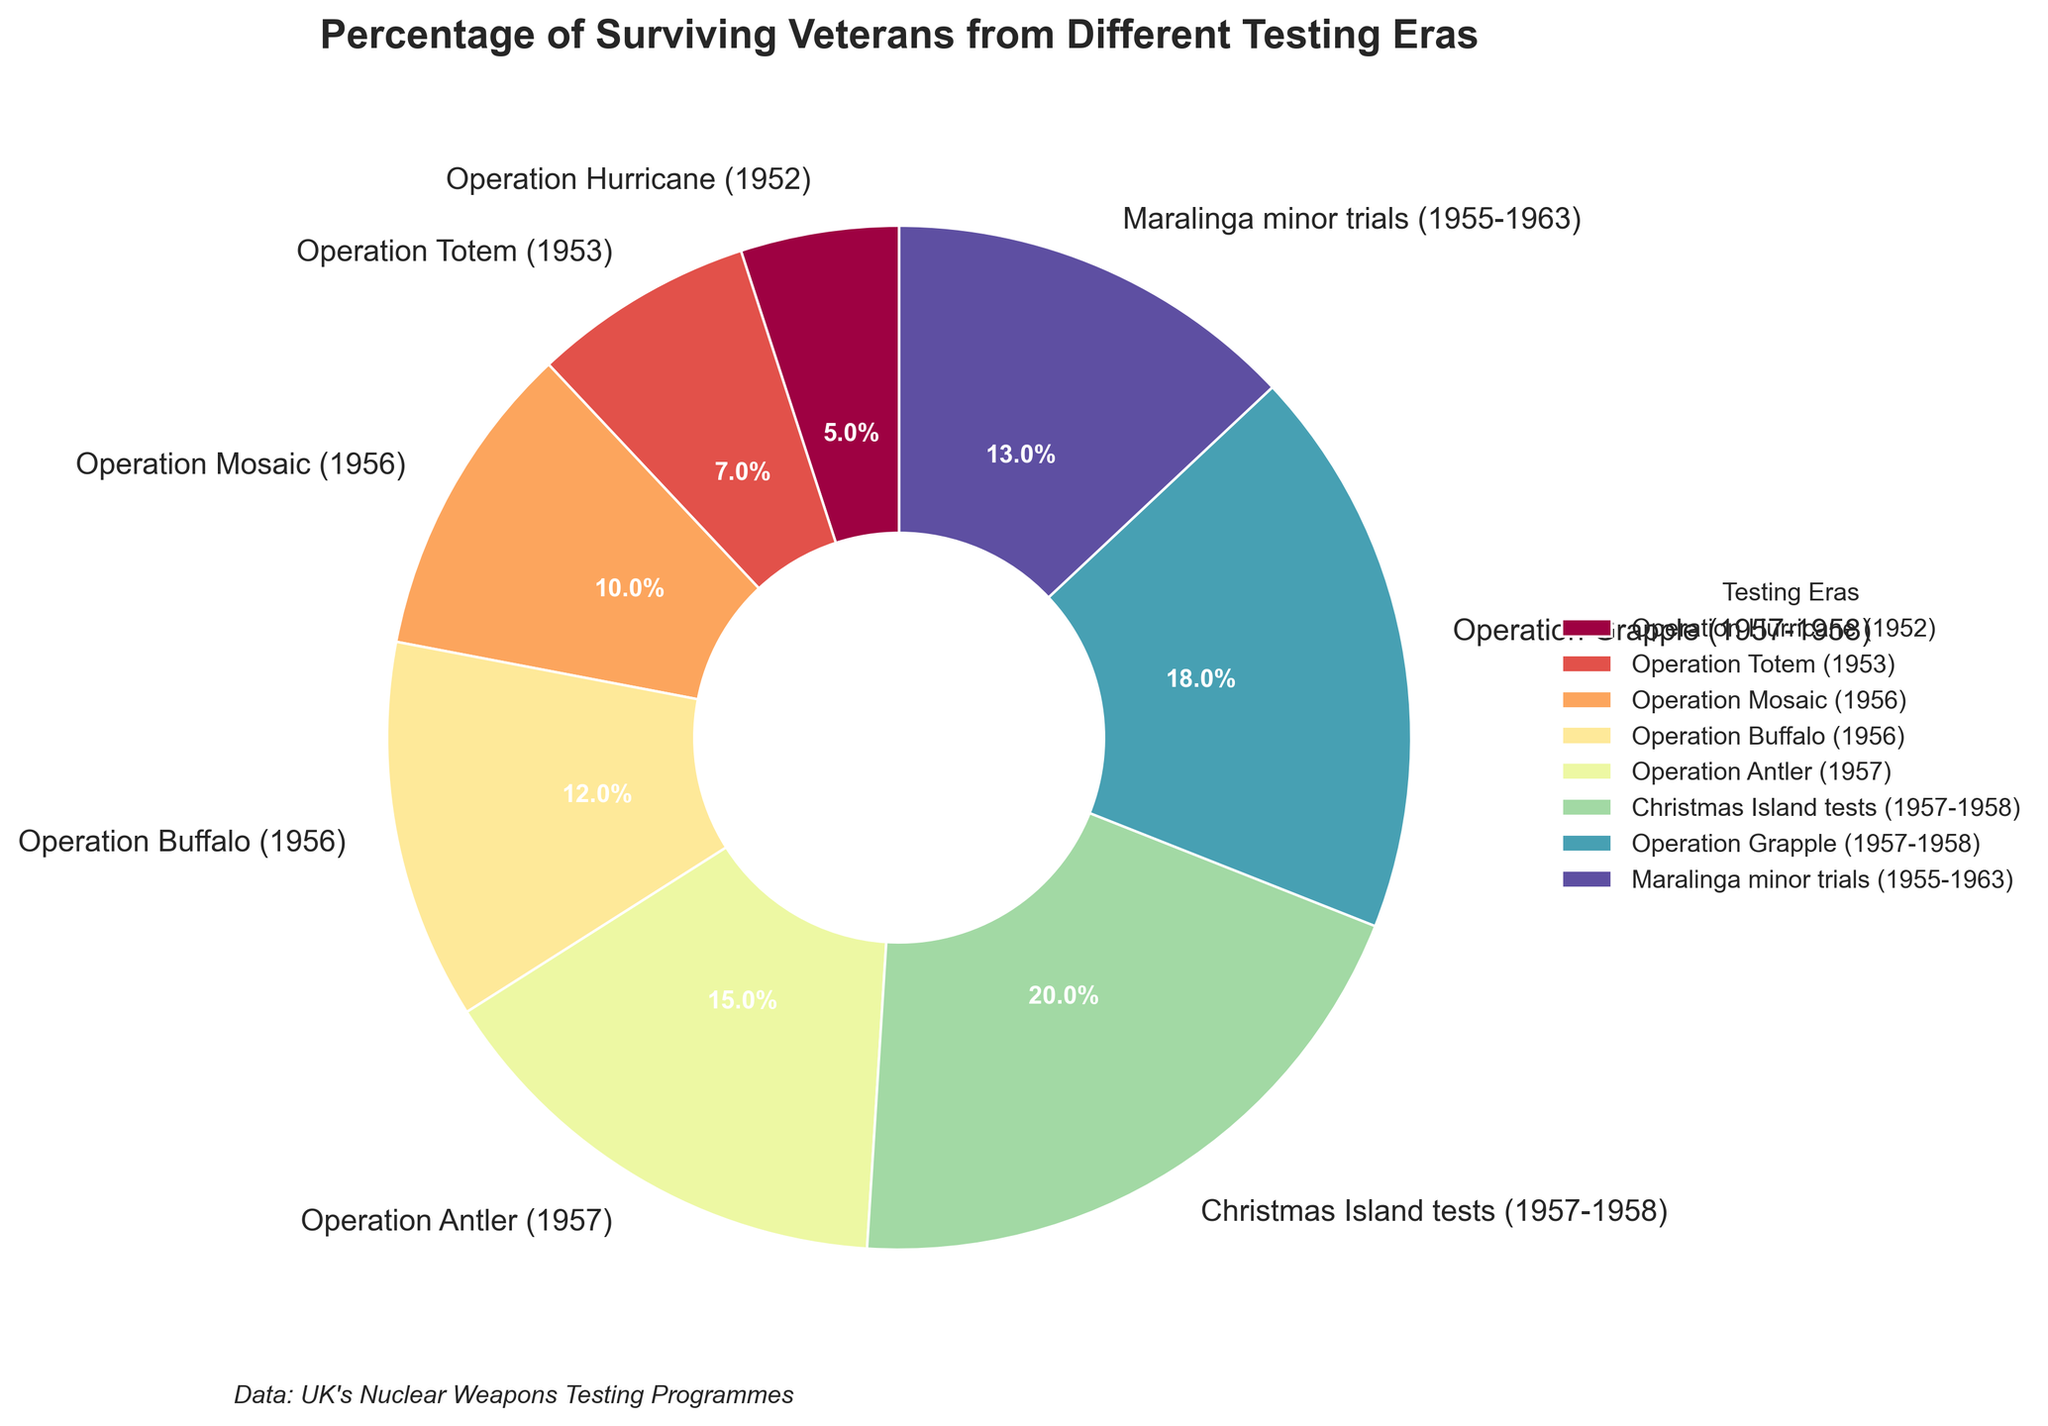What's the percentage of surviving veterans from the Christmas Island tests? Look for the Christmas Island tests slice in the pie chart and check the percentage label next to it. The figure shows an orange slice labeled "20.0%".
Answer: 20% Which testing era has the highest percentage of surviving veterans? Identify the slice in the pie chart with the largest percentage label. The largest slice corresponds to the Christmas Island tests with 20%.
Answer: Christmas Island tests Compare the percentage of surviving veterans from Operation Buffalo with Operation Grapple. Which one is higher? Locate the segments for Operation Buffalo and Operation Grapple. Operation Buffalo is labeled with 12%, while Operation Grapple is labeled with 18%. Operation Grapple has a higher percentage.
Answer: Operation Grapple What is the combined percentage of surviving veterans from Operation Hurricane and Operation Totem? Add the percentages from Operation Hurricane and Operation Totem. Operation Hurricane is 5% and Operation Totem is 7%. Combined, it's 5% + 7% = 12%.
Answer: 12% Is the percentage of surviving veterans from Operation Mosaic higher or lower than the Maralinga minor trials? Compare the labels for both testing eras. Operation Mosaic has 10%, and Maralinga minor trials have 13%. Therefore, Operation Mosaic is lower.
Answer: Lower What is the average percentage of surviving veterans across all testing eras? Sum the percentages of all eras and divide by the total number of eras (8). The sum is 5% + 7% + 10% + 12% + 15% + 20% + 18% + 13% = 100%. The average is 100% / 8 = 12.5%.
Answer: 12.5% Which testing eras have a percentage of surviving veterans that is greater than 15%? Identify slices with percentages greater than 15%. Christmas Island tests (20%), and Operation Grapple (18%) meet this criterion.
Answer: Christmas Island tests, Operation Grapple What is the smallest percentage of surviving veterans among the testing eras, and which era does it correspond to? Find the slice with the smallest percentage label in the chart. The smallest percentage is 5%, which corresponds to Operation Hurricane.
Answer: 5%, Operation Hurricane How many testing eras have a percentage of surviving veterans between 10% and 20% inclusive? Count the segments with percentages in the range 10% to 20%. The eras are Operation Mosaic (10%), Operation Buffalo (12%), Operation Antler (15%), Maralinga minor trials (13%), Operation Grapple (18%), and Christmas Island tests (20%). That makes 6 testing eras.
Answer: 6 